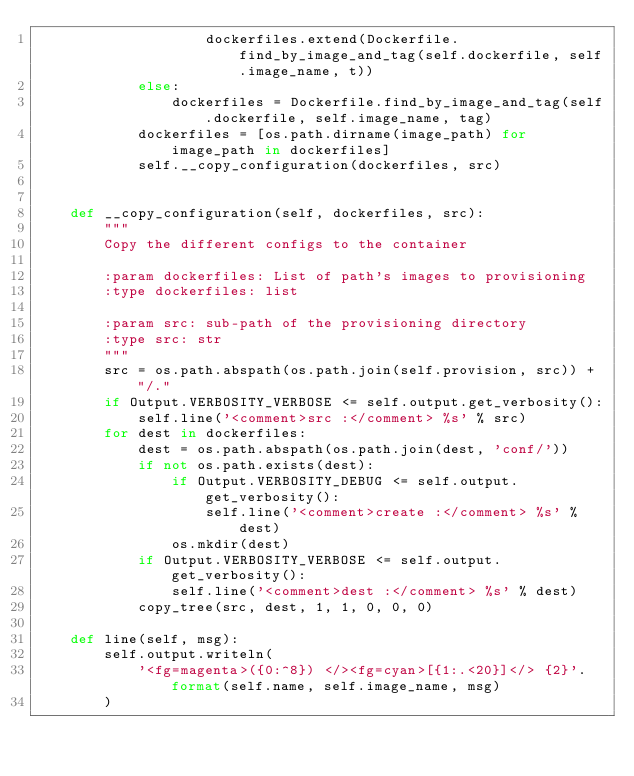<code> <loc_0><loc_0><loc_500><loc_500><_Python_>                    dockerfiles.extend(Dockerfile.find_by_image_and_tag(self.dockerfile, self.image_name, t))
            else:
                dockerfiles = Dockerfile.find_by_image_and_tag(self.dockerfile, self.image_name, tag)
            dockerfiles = [os.path.dirname(image_path) for image_path in dockerfiles]
            self.__copy_configuration(dockerfiles, src)


    def __copy_configuration(self, dockerfiles, src):
        """
        Copy the different configs to the container

        :param dockerfiles: List of path's images to provisioning
        :type dockerfiles: list

        :param src: sub-path of the provisioning directory
        :type src: str
        """
        src = os.path.abspath(os.path.join(self.provision, src)) + "/."
        if Output.VERBOSITY_VERBOSE <= self.output.get_verbosity():
            self.line('<comment>src :</comment> %s' % src)
        for dest in dockerfiles:
            dest = os.path.abspath(os.path.join(dest, 'conf/'))
            if not os.path.exists(dest):
                if Output.VERBOSITY_DEBUG <= self.output.get_verbosity():
                    self.line('<comment>create :</comment> %s' % dest)
                os.mkdir(dest)
            if Output.VERBOSITY_VERBOSE <= self.output.get_verbosity():
                self.line('<comment>dest :</comment> %s' % dest)
            copy_tree(src, dest, 1, 1, 0, 0, 0)

    def line(self, msg):
        self.output.writeln(
            '<fg=magenta>({0:^8}) </><fg=cyan>[{1:.<20}]</> {2}'.format(self.name, self.image_name, msg)
        )
</code> 